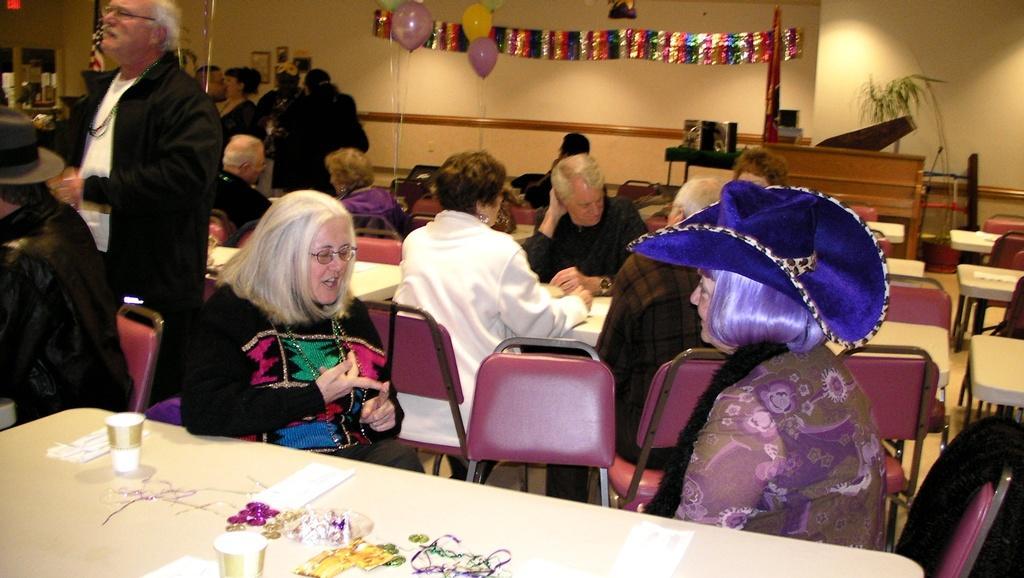Could you give a brief overview of what you see in this image? In this image there are people sitting on chairs, and there are tables, on one table there are cups, papers and other items and few persons are standing, in the background there is a wall on that wall there is a banner and balloons. 